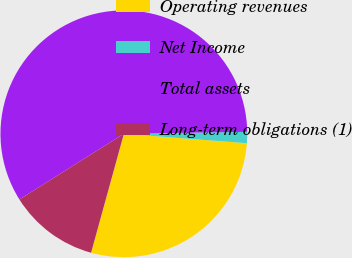<chart> <loc_0><loc_0><loc_500><loc_500><pie_chart><fcel>Operating revenues<fcel>Net Income<fcel>Total assets<fcel>Long-term obligations (1)<nl><fcel>28.07%<fcel>1.47%<fcel>58.68%<fcel>11.79%<nl></chart> 